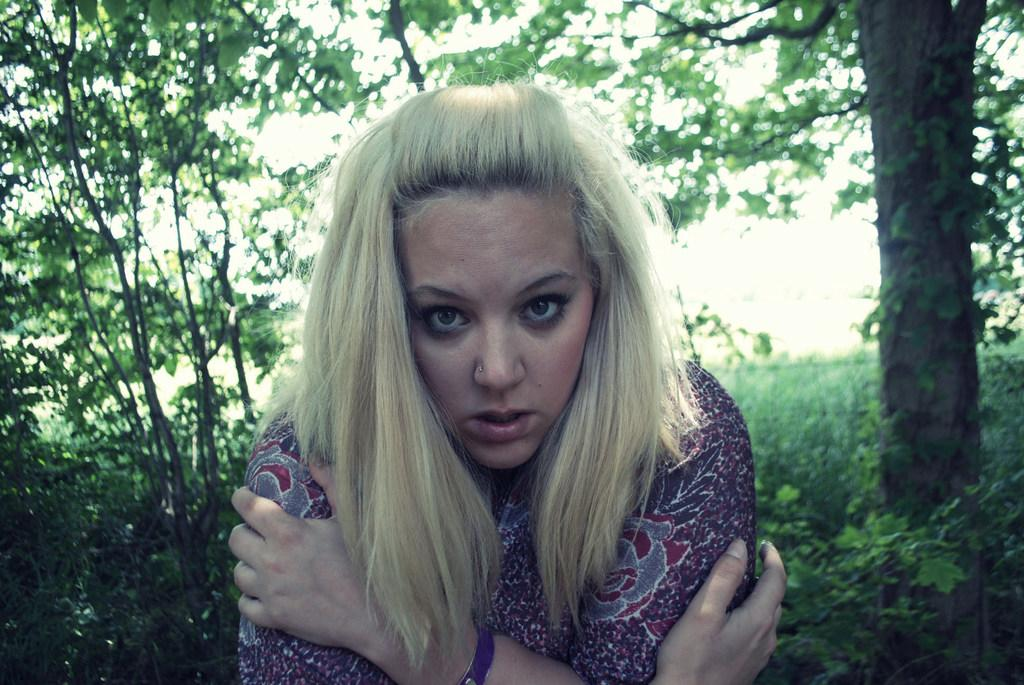What is the main subject of the image? There is a person in the image. What can be seen in the background of the image? There are plants and trees in the background of the image. What is the person's position in the image? The person's position in the image cannot be determined from the provided facts. What type of nail is visible in the image? There is no nail present in the image. 